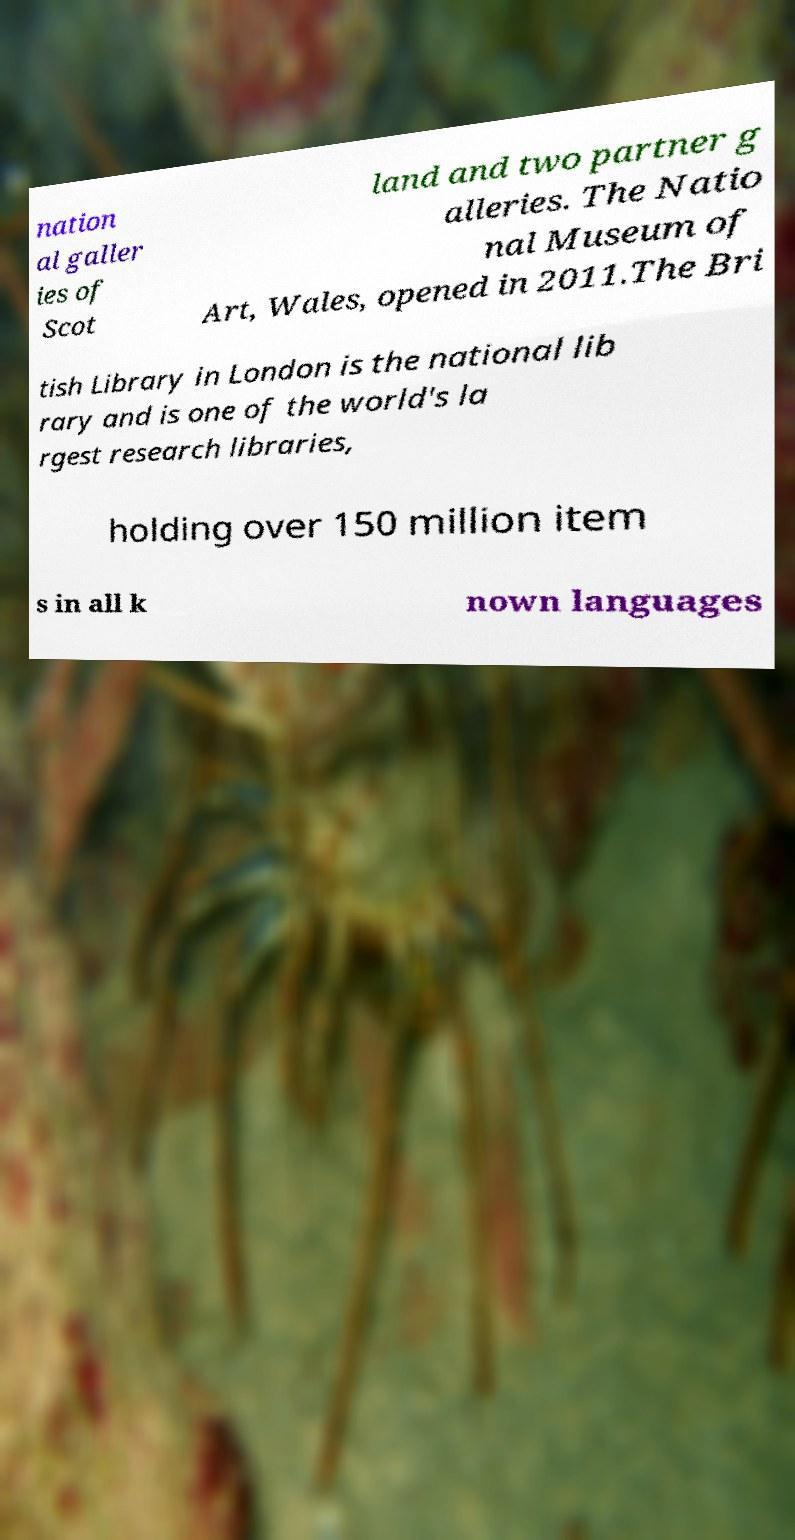Please identify and transcribe the text found in this image. nation al galler ies of Scot land and two partner g alleries. The Natio nal Museum of Art, Wales, opened in 2011.The Bri tish Library in London is the national lib rary and is one of the world's la rgest research libraries, holding over 150 million item s in all k nown languages 